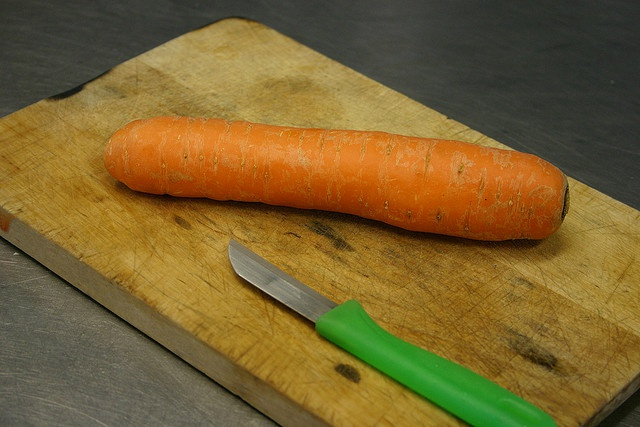Describe the objects in this image and their specific colors. I can see carrot in black, orange, red, and maroon tones and knife in black, green, and gray tones in this image. 